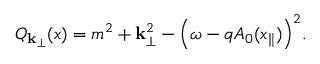<formula> <loc_0><loc_0><loc_500><loc_500>Q _ { { k } _ { \perp } } ( x ) = m ^ { 2 } + { k } _ { \perp } ^ { 2 } - \left ( \omega - q A _ { 0 } ( x _ { \| } ) \right ) ^ { 2 } .</formula> 